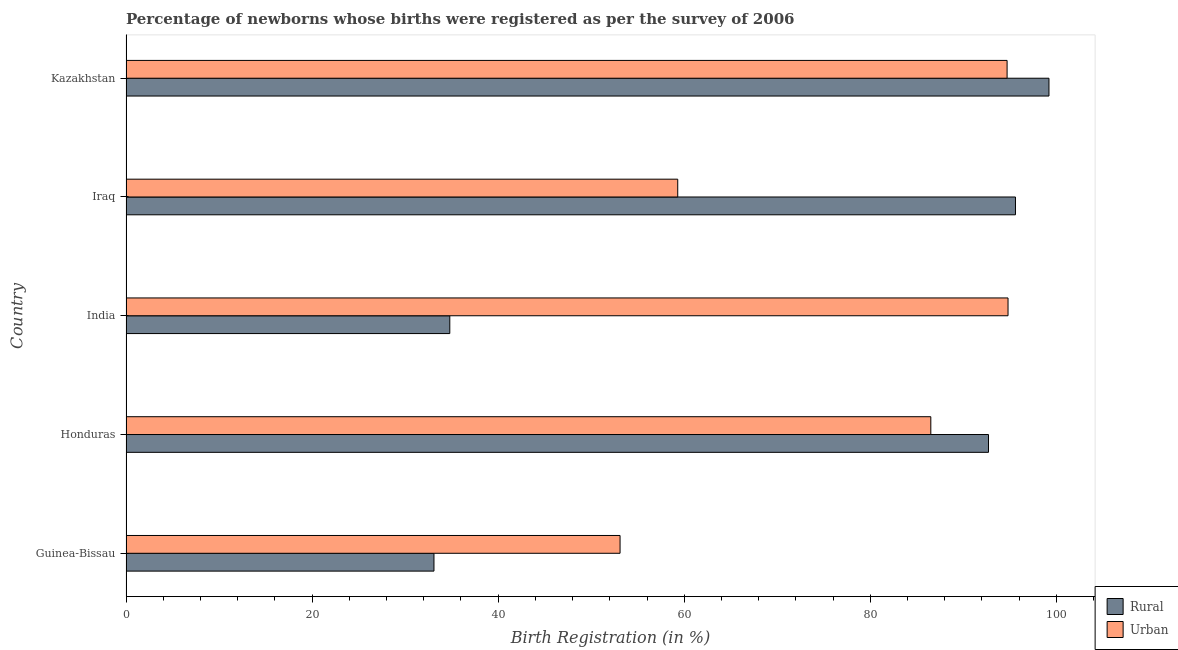How many groups of bars are there?
Your response must be concise. 5. How many bars are there on the 1st tick from the bottom?
Provide a succinct answer. 2. What is the label of the 5th group of bars from the top?
Offer a very short reply. Guinea-Bissau. What is the urban birth registration in Iraq?
Your response must be concise. 59.3. Across all countries, what is the maximum rural birth registration?
Ensure brevity in your answer.  99.2. Across all countries, what is the minimum urban birth registration?
Your answer should be compact. 53.1. In which country was the rural birth registration maximum?
Your answer should be very brief. Kazakhstan. In which country was the urban birth registration minimum?
Offer a terse response. Guinea-Bissau. What is the total rural birth registration in the graph?
Offer a very short reply. 355.4. What is the difference between the rural birth registration in Guinea-Bissau and that in Honduras?
Offer a very short reply. -59.6. What is the difference between the urban birth registration in Honduras and the rural birth registration in Iraq?
Offer a terse response. -9.1. What is the average rural birth registration per country?
Offer a very short reply. 71.08. What is the difference between the urban birth registration and rural birth registration in Honduras?
Provide a succinct answer. -6.2. What is the ratio of the rural birth registration in Honduras to that in Iraq?
Provide a short and direct response. 0.97. What is the difference between the highest and the lowest rural birth registration?
Offer a very short reply. 66.1. What does the 2nd bar from the top in Iraq represents?
Ensure brevity in your answer.  Rural. What does the 1st bar from the bottom in Iraq represents?
Offer a very short reply. Rural. What is the difference between two consecutive major ticks on the X-axis?
Your answer should be compact. 20. Are the values on the major ticks of X-axis written in scientific E-notation?
Make the answer very short. No. Does the graph contain grids?
Ensure brevity in your answer.  No. How many legend labels are there?
Provide a short and direct response. 2. How are the legend labels stacked?
Provide a short and direct response. Vertical. What is the title of the graph?
Offer a terse response. Percentage of newborns whose births were registered as per the survey of 2006. Does "Agricultural land" appear as one of the legend labels in the graph?
Provide a short and direct response. No. What is the label or title of the X-axis?
Your answer should be very brief. Birth Registration (in %). What is the Birth Registration (in %) of Rural in Guinea-Bissau?
Your answer should be very brief. 33.1. What is the Birth Registration (in %) in Urban in Guinea-Bissau?
Your answer should be compact. 53.1. What is the Birth Registration (in %) in Rural in Honduras?
Your response must be concise. 92.7. What is the Birth Registration (in %) in Urban in Honduras?
Keep it short and to the point. 86.5. What is the Birth Registration (in %) in Rural in India?
Offer a very short reply. 34.8. What is the Birth Registration (in %) of Urban in India?
Make the answer very short. 94.8. What is the Birth Registration (in %) of Rural in Iraq?
Make the answer very short. 95.6. What is the Birth Registration (in %) of Urban in Iraq?
Offer a very short reply. 59.3. What is the Birth Registration (in %) in Rural in Kazakhstan?
Provide a short and direct response. 99.2. What is the Birth Registration (in %) in Urban in Kazakhstan?
Keep it short and to the point. 94.7. Across all countries, what is the maximum Birth Registration (in %) in Rural?
Offer a terse response. 99.2. Across all countries, what is the maximum Birth Registration (in %) in Urban?
Make the answer very short. 94.8. Across all countries, what is the minimum Birth Registration (in %) in Rural?
Ensure brevity in your answer.  33.1. Across all countries, what is the minimum Birth Registration (in %) of Urban?
Offer a very short reply. 53.1. What is the total Birth Registration (in %) in Rural in the graph?
Your response must be concise. 355.4. What is the total Birth Registration (in %) in Urban in the graph?
Your response must be concise. 388.4. What is the difference between the Birth Registration (in %) in Rural in Guinea-Bissau and that in Honduras?
Ensure brevity in your answer.  -59.6. What is the difference between the Birth Registration (in %) of Urban in Guinea-Bissau and that in Honduras?
Ensure brevity in your answer.  -33.4. What is the difference between the Birth Registration (in %) of Urban in Guinea-Bissau and that in India?
Provide a succinct answer. -41.7. What is the difference between the Birth Registration (in %) of Rural in Guinea-Bissau and that in Iraq?
Your answer should be very brief. -62.5. What is the difference between the Birth Registration (in %) of Urban in Guinea-Bissau and that in Iraq?
Offer a very short reply. -6.2. What is the difference between the Birth Registration (in %) in Rural in Guinea-Bissau and that in Kazakhstan?
Provide a succinct answer. -66.1. What is the difference between the Birth Registration (in %) in Urban in Guinea-Bissau and that in Kazakhstan?
Your response must be concise. -41.6. What is the difference between the Birth Registration (in %) in Rural in Honduras and that in India?
Your answer should be compact. 57.9. What is the difference between the Birth Registration (in %) in Urban in Honduras and that in India?
Keep it short and to the point. -8.3. What is the difference between the Birth Registration (in %) in Rural in Honduras and that in Iraq?
Provide a succinct answer. -2.9. What is the difference between the Birth Registration (in %) in Urban in Honduras and that in Iraq?
Ensure brevity in your answer.  27.2. What is the difference between the Birth Registration (in %) in Rural in India and that in Iraq?
Keep it short and to the point. -60.8. What is the difference between the Birth Registration (in %) in Urban in India and that in Iraq?
Offer a very short reply. 35.5. What is the difference between the Birth Registration (in %) in Rural in India and that in Kazakhstan?
Your answer should be compact. -64.4. What is the difference between the Birth Registration (in %) of Urban in India and that in Kazakhstan?
Your response must be concise. 0.1. What is the difference between the Birth Registration (in %) in Urban in Iraq and that in Kazakhstan?
Your answer should be very brief. -35.4. What is the difference between the Birth Registration (in %) in Rural in Guinea-Bissau and the Birth Registration (in %) in Urban in Honduras?
Your answer should be very brief. -53.4. What is the difference between the Birth Registration (in %) in Rural in Guinea-Bissau and the Birth Registration (in %) in Urban in India?
Offer a terse response. -61.7. What is the difference between the Birth Registration (in %) of Rural in Guinea-Bissau and the Birth Registration (in %) of Urban in Iraq?
Ensure brevity in your answer.  -26.2. What is the difference between the Birth Registration (in %) in Rural in Guinea-Bissau and the Birth Registration (in %) in Urban in Kazakhstan?
Offer a terse response. -61.6. What is the difference between the Birth Registration (in %) of Rural in Honduras and the Birth Registration (in %) of Urban in Iraq?
Give a very brief answer. 33.4. What is the difference between the Birth Registration (in %) of Rural in India and the Birth Registration (in %) of Urban in Iraq?
Offer a terse response. -24.5. What is the difference between the Birth Registration (in %) in Rural in India and the Birth Registration (in %) in Urban in Kazakhstan?
Your answer should be compact. -59.9. What is the difference between the Birth Registration (in %) in Rural in Iraq and the Birth Registration (in %) in Urban in Kazakhstan?
Offer a terse response. 0.9. What is the average Birth Registration (in %) of Rural per country?
Offer a terse response. 71.08. What is the average Birth Registration (in %) in Urban per country?
Offer a very short reply. 77.68. What is the difference between the Birth Registration (in %) of Rural and Birth Registration (in %) of Urban in Guinea-Bissau?
Keep it short and to the point. -20. What is the difference between the Birth Registration (in %) of Rural and Birth Registration (in %) of Urban in Honduras?
Your answer should be very brief. 6.2. What is the difference between the Birth Registration (in %) in Rural and Birth Registration (in %) in Urban in India?
Provide a short and direct response. -60. What is the difference between the Birth Registration (in %) in Rural and Birth Registration (in %) in Urban in Iraq?
Provide a succinct answer. 36.3. What is the difference between the Birth Registration (in %) in Rural and Birth Registration (in %) in Urban in Kazakhstan?
Offer a very short reply. 4.5. What is the ratio of the Birth Registration (in %) of Rural in Guinea-Bissau to that in Honduras?
Offer a terse response. 0.36. What is the ratio of the Birth Registration (in %) in Urban in Guinea-Bissau to that in Honduras?
Your response must be concise. 0.61. What is the ratio of the Birth Registration (in %) of Rural in Guinea-Bissau to that in India?
Make the answer very short. 0.95. What is the ratio of the Birth Registration (in %) in Urban in Guinea-Bissau to that in India?
Provide a succinct answer. 0.56. What is the ratio of the Birth Registration (in %) of Rural in Guinea-Bissau to that in Iraq?
Offer a terse response. 0.35. What is the ratio of the Birth Registration (in %) of Urban in Guinea-Bissau to that in Iraq?
Provide a succinct answer. 0.9. What is the ratio of the Birth Registration (in %) of Rural in Guinea-Bissau to that in Kazakhstan?
Make the answer very short. 0.33. What is the ratio of the Birth Registration (in %) of Urban in Guinea-Bissau to that in Kazakhstan?
Keep it short and to the point. 0.56. What is the ratio of the Birth Registration (in %) in Rural in Honduras to that in India?
Offer a terse response. 2.66. What is the ratio of the Birth Registration (in %) in Urban in Honduras to that in India?
Your answer should be very brief. 0.91. What is the ratio of the Birth Registration (in %) of Rural in Honduras to that in Iraq?
Your response must be concise. 0.97. What is the ratio of the Birth Registration (in %) of Urban in Honduras to that in Iraq?
Your answer should be compact. 1.46. What is the ratio of the Birth Registration (in %) in Rural in Honduras to that in Kazakhstan?
Ensure brevity in your answer.  0.93. What is the ratio of the Birth Registration (in %) in Urban in Honduras to that in Kazakhstan?
Keep it short and to the point. 0.91. What is the ratio of the Birth Registration (in %) in Rural in India to that in Iraq?
Keep it short and to the point. 0.36. What is the ratio of the Birth Registration (in %) in Urban in India to that in Iraq?
Your answer should be compact. 1.6. What is the ratio of the Birth Registration (in %) in Rural in India to that in Kazakhstan?
Provide a succinct answer. 0.35. What is the ratio of the Birth Registration (in %) in Urban in India to that in Kazakhstan?
Provide a succinct answer. 1. What is the ratio of the Birth Registration (in %) of Rural in Iraq to that in Kazakhstan?
Your response must be concise. 0.96. What is the ratio of the Birth Registration (in %) in Urban in Iraq to that in Kazakhstan?
Ensure brevity in your answer.  0.63. What is the difference between the highest and the lowest Birth Registration (in %) in Rural?
Ensure brevity in your answer.  66.1. What is the difference between the highest and the lowest Birth Registration (in %) of Urban?
Offer a terse response. 41.7. 